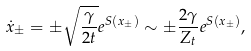Convert formula to latex. <formula><loc_0><loc_0><loc_500><loc_500>\dot { x } _ { \pm } = \pm \sqrt { \frac { \gamma } { 2 t } } e ^ { S ( x _ { \pm } ) } \sim \pm \frac { 2 \gamma } { Z _ { t } } e ^ { S ( x _ { \pm } ) } ,</formula> 